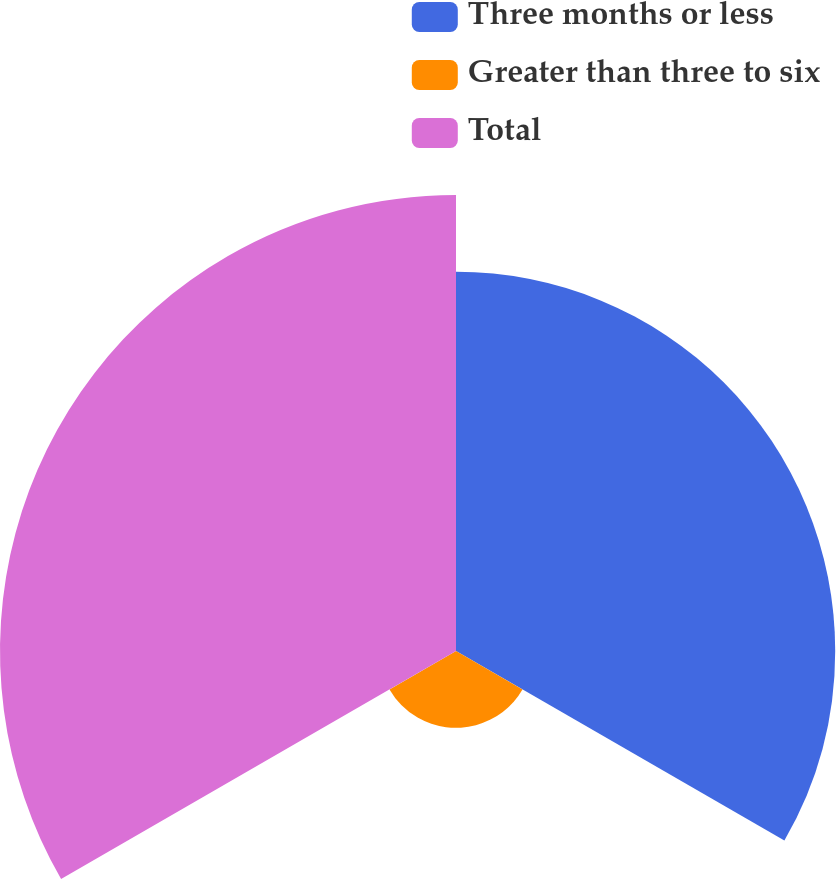Convert chart. <chart><loc_0><loc_0><loc_500><loc_500><pie_chart><fcel>Three months or less<fcel>Greater than three to six<fcel>Total<nl><fcel>41.58%<fcel>8.42%<fcel>50.0%<nl></chart> 